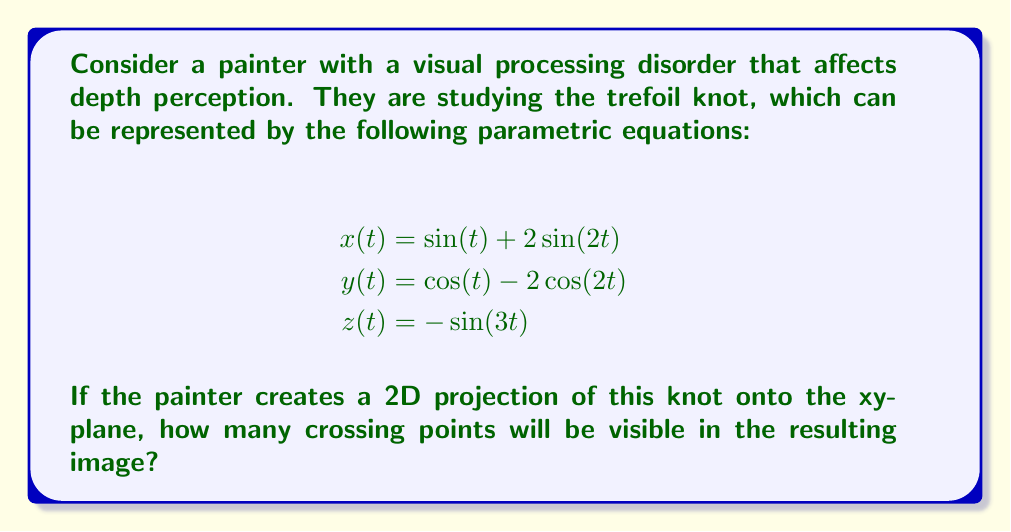Provide a solution to this math problem. To solve this problem, we need to follow these steps:

1. Understand the trefoil knot:
   The trefoil knot is one of the simplest non-trivial knots in knot theory.

2. Analyze the 2D projection:
   When projecting the 3D trefoil knot onto the xy-plane, we essentially ignore the z-coordinate.

3. Determine crossing points:
   Crossing points occur when the projected curve intersects itself in the 2D plane.

4. Count the crossing points:
   For the trefoil knot, the standard projection results in three crossing points.

5. Consider the visual processing disorder:
   The painter's depth perception issue doesn't affect the mathematical properties of the projection. The number of crossing points remains constant regardless of the viewer's perception.

6. Verify the result:
   We can visualize this projection using Asymptote:

[asy]
import graph;
size(200);
real x(real t) {return sin(t) + 2*sin(2*t);}
real y(real t) {return cos(t) - 2*cos(2*t);}
path p = graph(x, y, 0, 2pi, 200);
draw(p, blue);
dot((x(0),y(0)), red);
dot((x(2pi/3),y(2pi/3)), red);
dot((x(4pi/3),y(4pi/3)), red);
[/asy]

   The red dots in the diagram represent the three crossing points.

Therefore, the 2D projection of the trefoil knot will have 3 crossing points visible in the resulting image.
Answer: 3 crossing points 